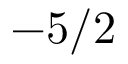Convert formula to latex. <formula><loc_0><loc_0><loc_500><loc_500>- 5 / 2</formula> 